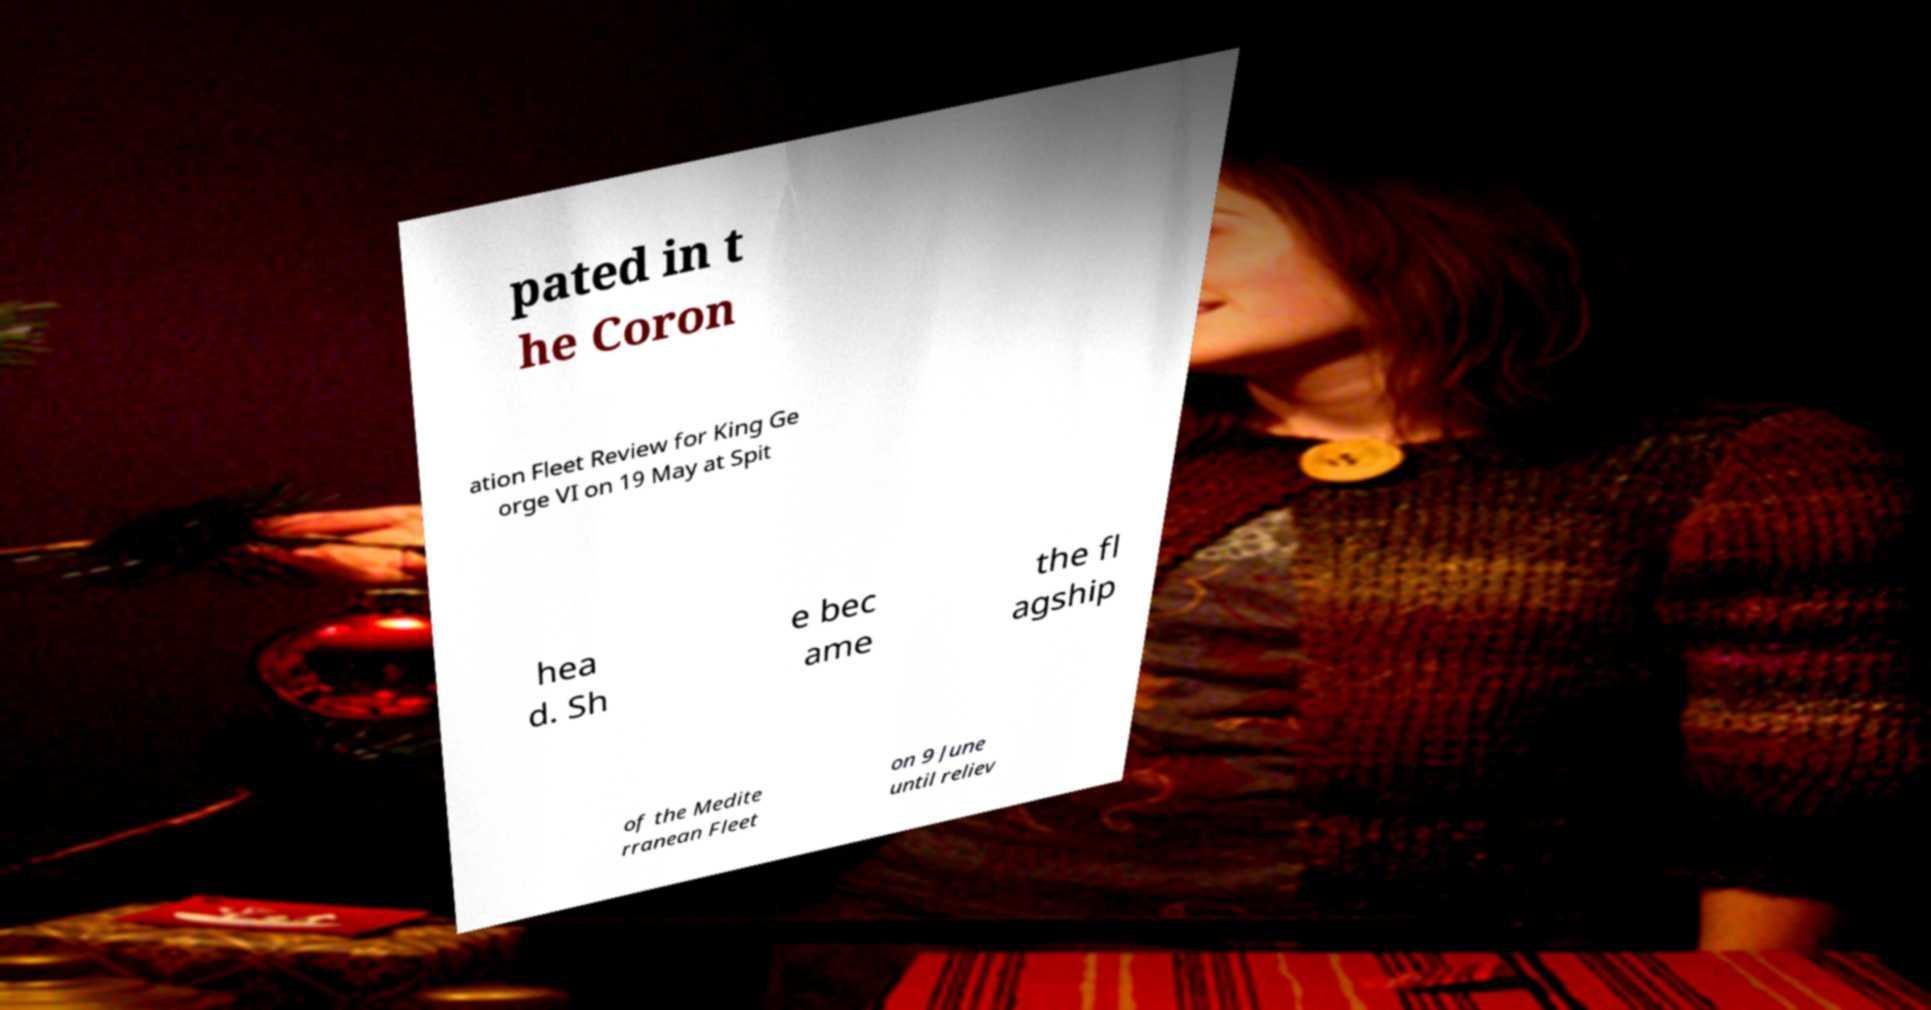For documentation purposes, I need the text within this image transcribed. Could you provide that? pated in t he Coron ation Fleet Review for King Ge orge VI on 19 May at Spit hea d. Sh e bec ame the fl agship of the Medite rranean Fleet on 9 June until reliev 